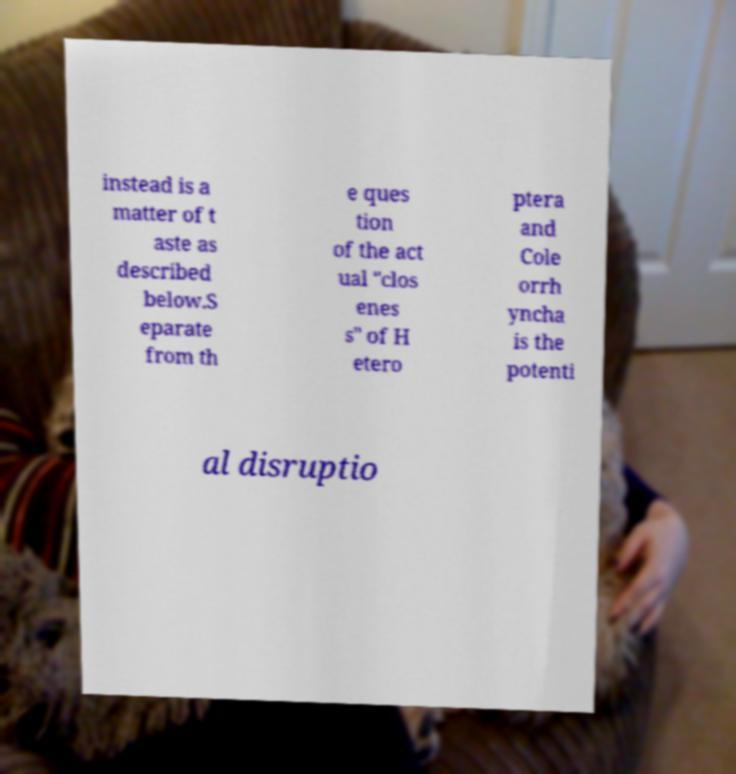Can you read and provide the text displayed in the image?This photo seems to have some interesting text. Can you extract and type it out for me? instead is a matter of t aste as described below.S eparate from th e ques tion of the act ual "clos enes s" of H etero ptera and Cole orrh yncha is the potenti al disruptio 